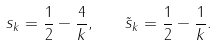<formula> <loc_0><loc_0><loc_500><loc_500>s _ { k } = \frac { 1 } { 2 } - \frac { 4 } { k } , \quad \tilde { s } _ { k } = \frac { 1 } { 2 } - \frac { 1 } { k } .</formula> 